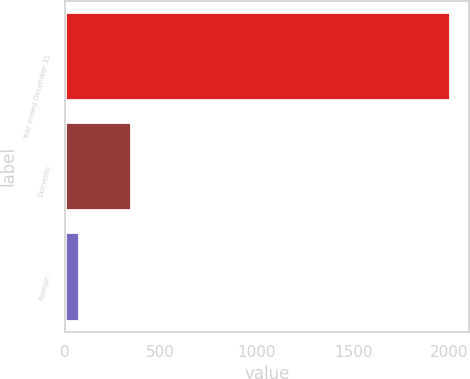Convert chart to OTSL. <chart><loc_0><loc_0><loc_500><loc_500><bar_chart><fcel>Year ended December 31<fcel>Domestic<fcel>Foreign<nl><fcel>2004<fcel>347.7<fcel>74.9<nl></chart> 